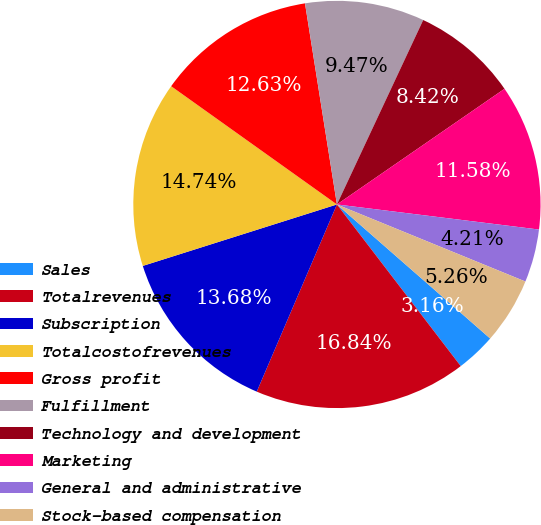Convert chart to OTSL. <chart><loc_0><loc_0><loc_500><loc_500><pie_chart><fcel>Sales<fcel>Totalrevenues<fcel>Subscription<fcel>Totalcostofrevenues<fcel>Gross profit<fcel>Fulfillment<fcel>Technology and development<fcel>Marketing<fcel>General and administrative<fcel>Stock-based compensation<nl><fcel>3.16%<fcel>16.84%<fcel>13.68%<fcel>14.74%<fcel>12.63%<fcel>9.47%<fcel>8.42%<fcel>11.58%<fcel>4.21%<fcel>5.26%<nl></chart> 